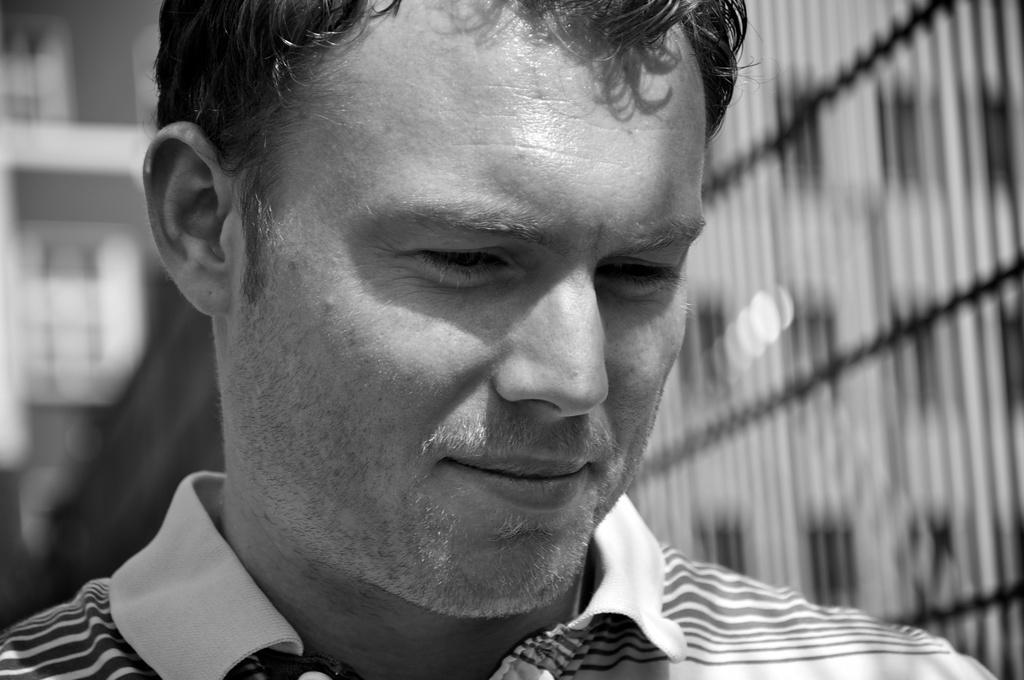Can you describe this image briefly? In this picture there is a man standing in the front, smiling and looking down. Behind there is a blur background with iron fencing grill. 